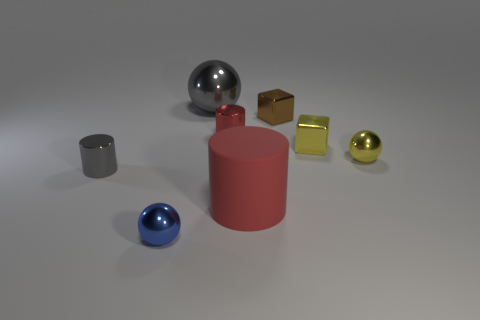How many other objects are there of the same shape as the small gray shiny thing?
Provide a succinct answer. 2. Are there more big things in front of the tiny gray metallic cylinder than red objects to the right of the large red rubber cylinder?
Your answer should be compact. Yes. Is the size of the shiny ball to the right of the big red cylinder the same as the gray object that is right of the tiny blue sphere?
Your answer should be very brief. No. There is a rubber object; what shape is it?
Ensure brevity in your answer.  Cylinder. The other metal cylinder that is the same color as the large cylinder is what size?
Ensure brevity in your answer.  Small. What color is the large thing that is made of the same material as the yellow block?
Keep it short and to the point. Gray. Do the big gray sphere and the red cylinder on the right side of the red shiny thing have the same material?
Offer a very short reply. No. What is the color of the large metallic ball?
Offer a very short reply. Gray. What is the size of the gray ball that is the same material as the small brown cube?
Offer a terse response. Large. There is a small metallic object that is left of the object in front of the matte thing; what number of rubber things are on the left side of it?
Your response must be concise. 0. 